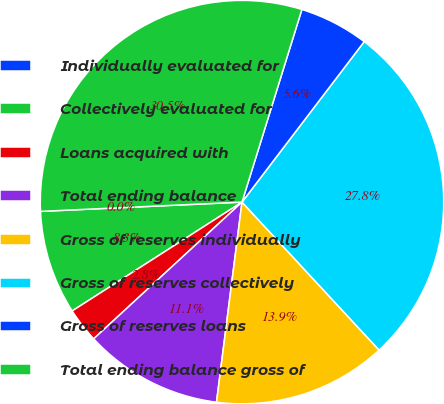Convert chart to OTSL. <chart><loc_0><loc_0><loc_500><loc_500><pie_chart><fcel>Individually evaluated for<fcel>Collectively evaluated for<fcel>Loans acquired with<fcel>Total ending balance<fcel>Gross of reserves individually<fcel>Gross of reserves collectively<fcel>Gross of reserves loans<fcel>Total ending balance gross of<nl><fcel>0.0%<fcel>8.34%<fcel>2.78%<fcel>11.13%<fcel>13.91%<fcel>27.75%<fcel>5.56%<fcel>30.53%<nl></chart> 